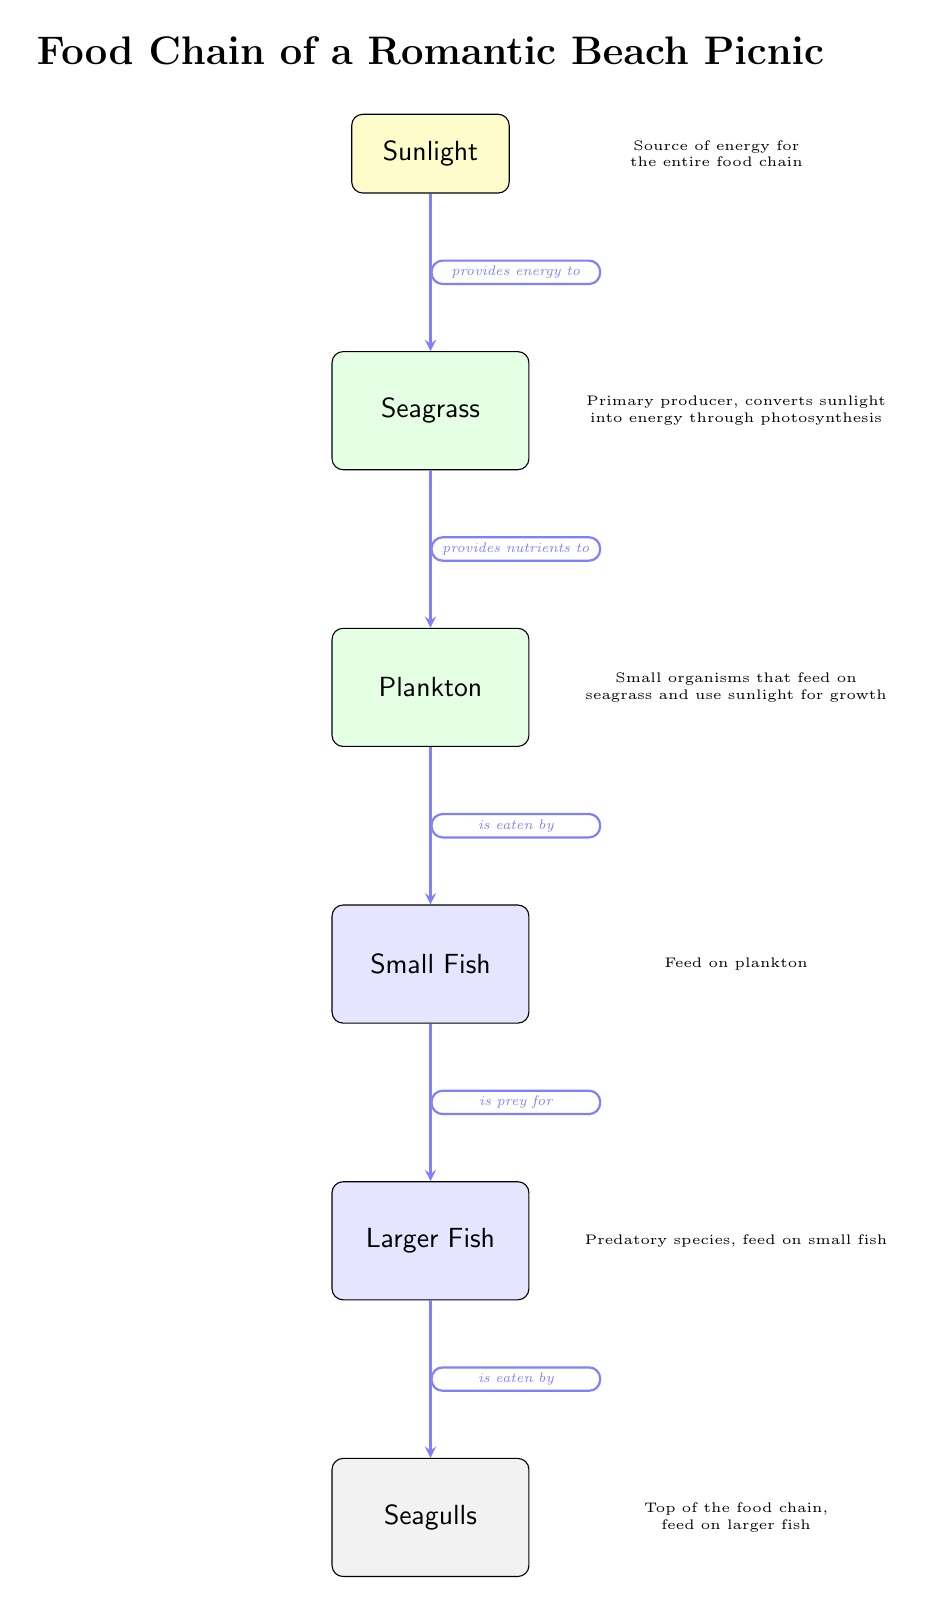What is the top organism in the food chain? The diagram shows that the organism at the bottom of the chain is the sunlight, and as we follow the arrows upwards, we see that the seagull is the last organism in the series, indicating it is at the top of the food chain.
Answer: Seagulls How many organisms are in the food chain? By counting the nodes in the diagram, we have six organisms (sunlight, seagrass, plankton, small fish, larger fish, seagull). Adding sunlight as a part of the chain brings the total to six entities.
Answer: 6 What nutrient does seagrass provide? According to the arrow from seagrass to plankton, seagrass provides nutrients, which is explicitly stated in the relationship between these two nodes in the diagram.
Answer: Nutrients Who is the primary producer in the food chain? The diagram identifies the seagrass as the primary producer, as it is connected directly to sunlight and converts it into energy through photosynthesis.
Answer: Seagrass Which organism is eaten by larger fish? Referring to the connection between small fish and larger fish in the diagram, we can observe that larger fish prey on small fish, so small fish is the one eaten by larger fish.
Answer: Small Fish What does sunlight provide to seagrass? Analyzing the direction of the arrow leading from sunlight to seagrass reveals that sunlight provides energy, making this connection clear in the diagram.
Answer: Energy What type of organisms are plankton categorized as? By examining the diagram, we see that plankton is a type of organism that feeds on seagrass, thus categorizing plankton as a primary consumer in the food chain structure.
Answer: Organisms Which organism is at the bottom of the food chain? The diagram visually displays sunlight at the top level, but as we trace downwards, seagrass is the first organism we encounter, indicating it’s at the bottom of the hierarchy in this food chain.
Answer: Seagrass 